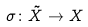Convert formula to latex. <formula><loc_0><loc_0><loc_500><loc_500>\sigma \colon \tilde { X } \rightarrow X</formula> 